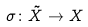Convert formula to latex. <formula><loc_0><loc_0><loc_500><loc_500>\sigma \colon \tilde { X } \rightarrow X</formula> 